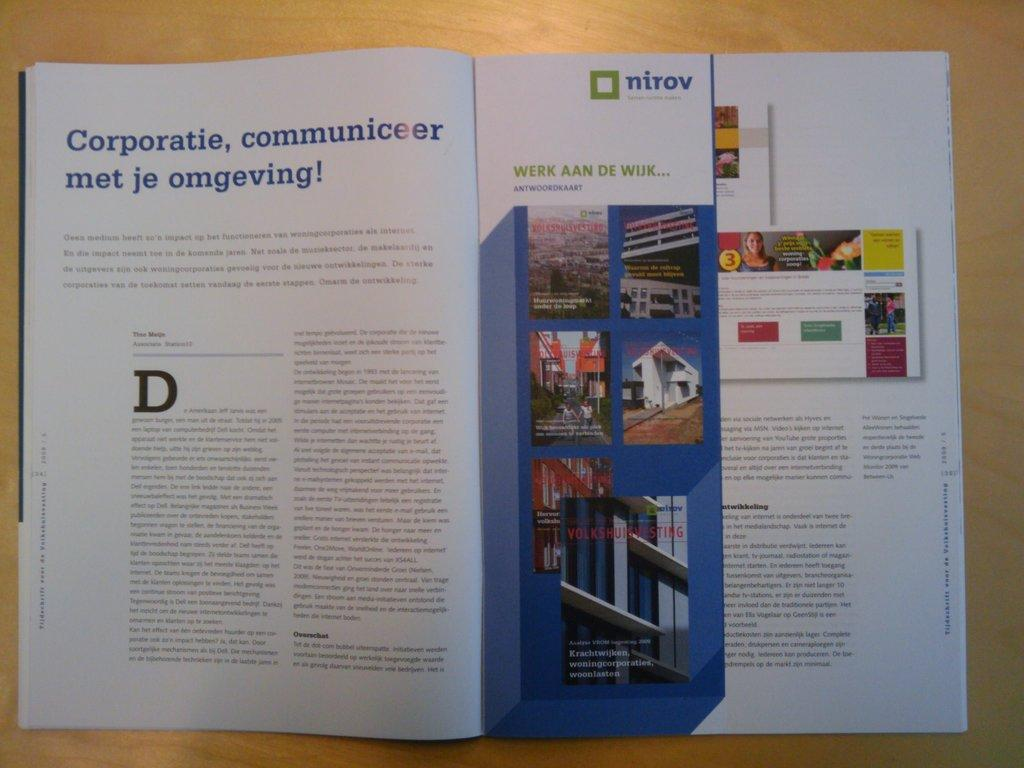<image>
Create a compact narrative representing the image presented. open book text book called nirov werk aa de wuk 